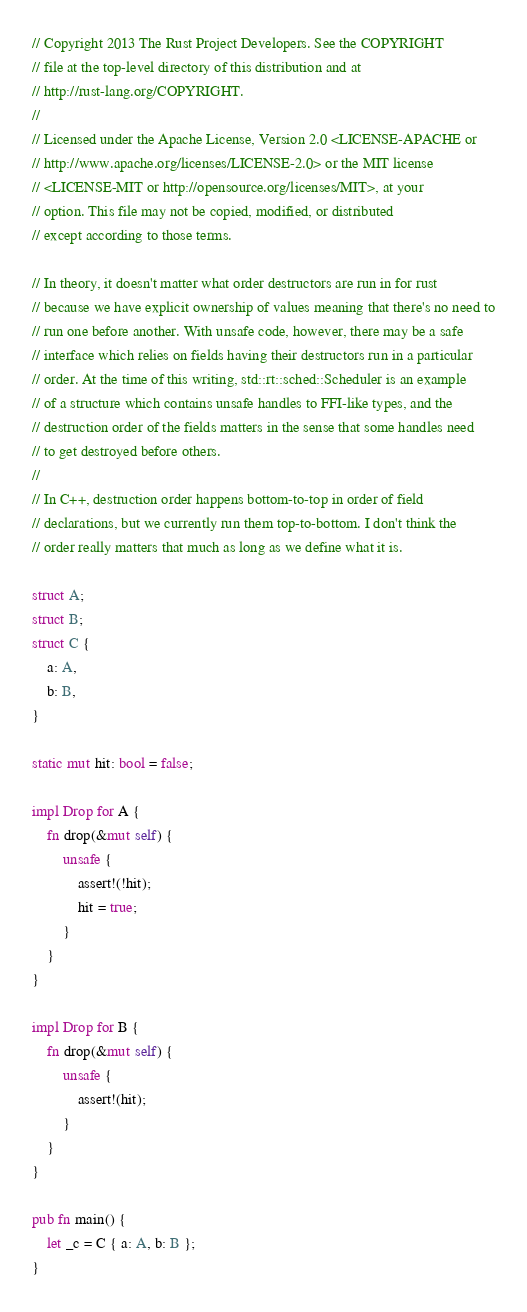<code> <loc_0><loc_0><loc_500><loc_500><_Rust_>// Copyright 2013 The Rust Project Developers. See the COPYRIGHT
// file at the top-level directory of this distribution and at
// http://rust-lang.org/COPYRIGHT.
//
// Licensed under the Apache License, Version 2.0 <LICENSE-APACHE or
// http://www.apache.org/licenses/LICENSE-2.0> or the MIT license
// <LICENSE-MIT or http://opensource.org/licenses/MIT>, at your
// option. This file may not be copied, modified, or distributed
// except according to those terms.

// In theory, it doesn't matter what order destructors are run in for rust
// because we have explicit ownership of values meaning that there's no need to
// run one before another. With unsafe code, however, there may be a safe
// interface which relies on fields having their destructors run in a particular
// order. At the time of this writing, std::rt::sched::Scheduler is an example
// of a structure which contains unsafe handles to FFI-like types, and the
// destruction order of the fields matters in the sense that some handles need
// to get destroyed before others.
//
// In C++, destruction order happens bottom-to-top in order of field
// declarations, but we currently run them top-to-bottom. I don't think the
// order really matters that much as long as we define what it is.

struct A;
struct B;
struct C {
    a: A,
    b: B,
}

static mut hit: bool = false;

impl Drop for A {
    fn drop(&mut self) {
        unsafe {
            assert!(!hit);
            hit = true;
        }
    }
}

impl Drop for B {
    fn drop(&mut self) {
        unsafe {
            assert!(hit);
        }
    }
}

pub fn main() {
    let _c = C { a: A, b: B };
}
</code> 